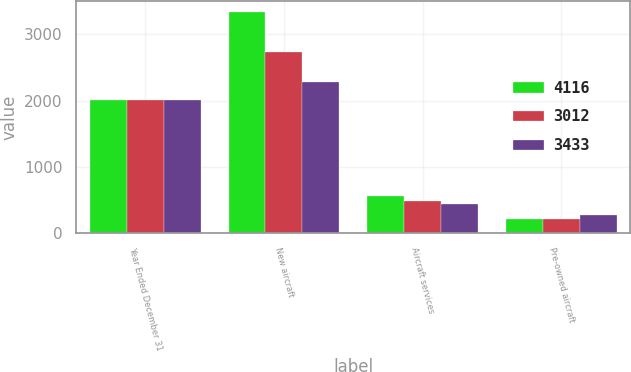Convert chart. <chart><loc_0><loc_0><loc_500><loc_500><stacked_bar_chart><ecel><fcel>Year Ended December 31<fcel>New aircraft<fcel>Aircraft services<fcel>Pre-owned aircraft<nl><fcel>4116<fcel>2006<fcel>3341<fcel>558<fcel>217<nl><fcel>3012<fcel>2005<fcel>2730<fcel>484<fcel>219<nl><fcel>3433<fcel>2004<fcel>2288<fcel>446<fcel>278<nl></chart> 